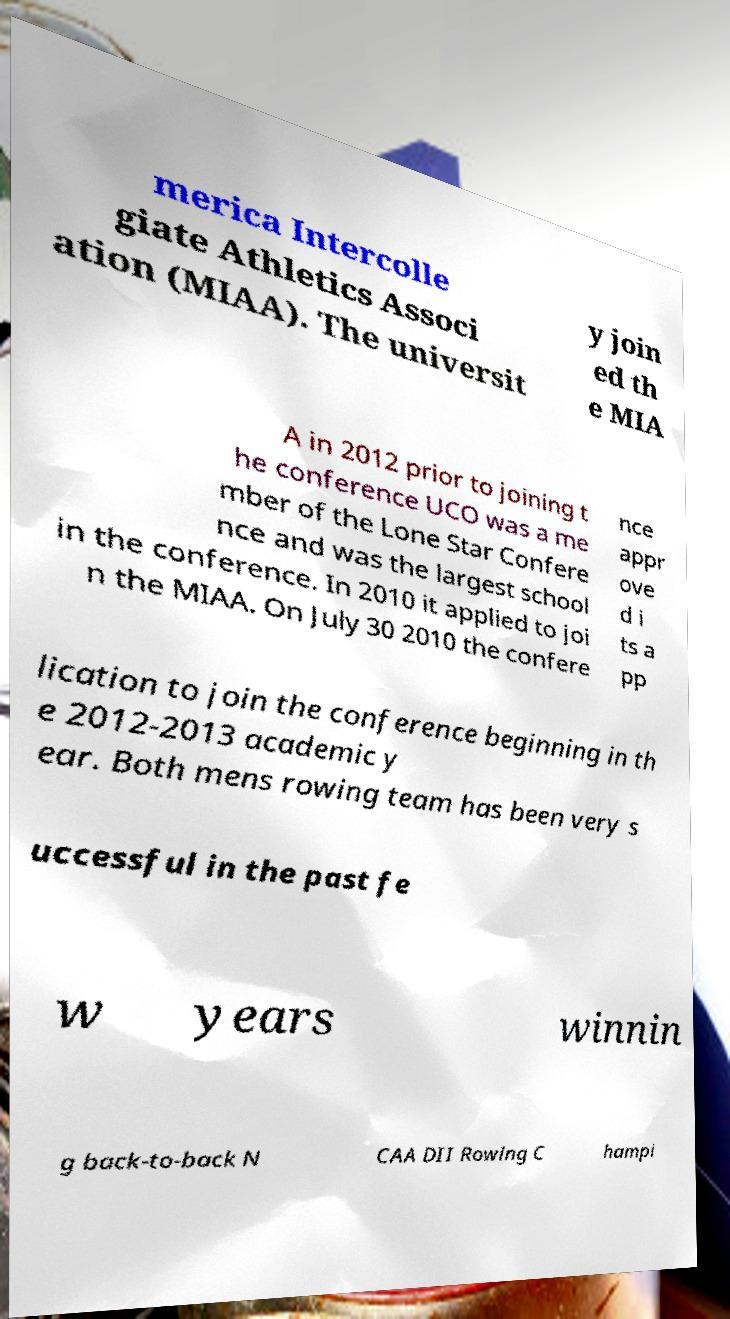There's text embedded in this image that I need extracted. Can you transcribe it verbatim? merica Intercolle giate Athletics Associ ation (MIAA). The universit y join ed th e MIA A in 2012 prior to joining t he conference UCO was a me mber of the Lone Star Confere nce and was the largest school in the conference. In 2010 it applied to joi n the MIAA. On July 30 2010 the confere nce appr ove d i ts a pp lication to join the conference beginning in th e 2012-2013 academic y ear. Both mens rowing team has been very s uccessful in the past fe w years winnin g back-to-back N CAA DII Rowing C hampi 